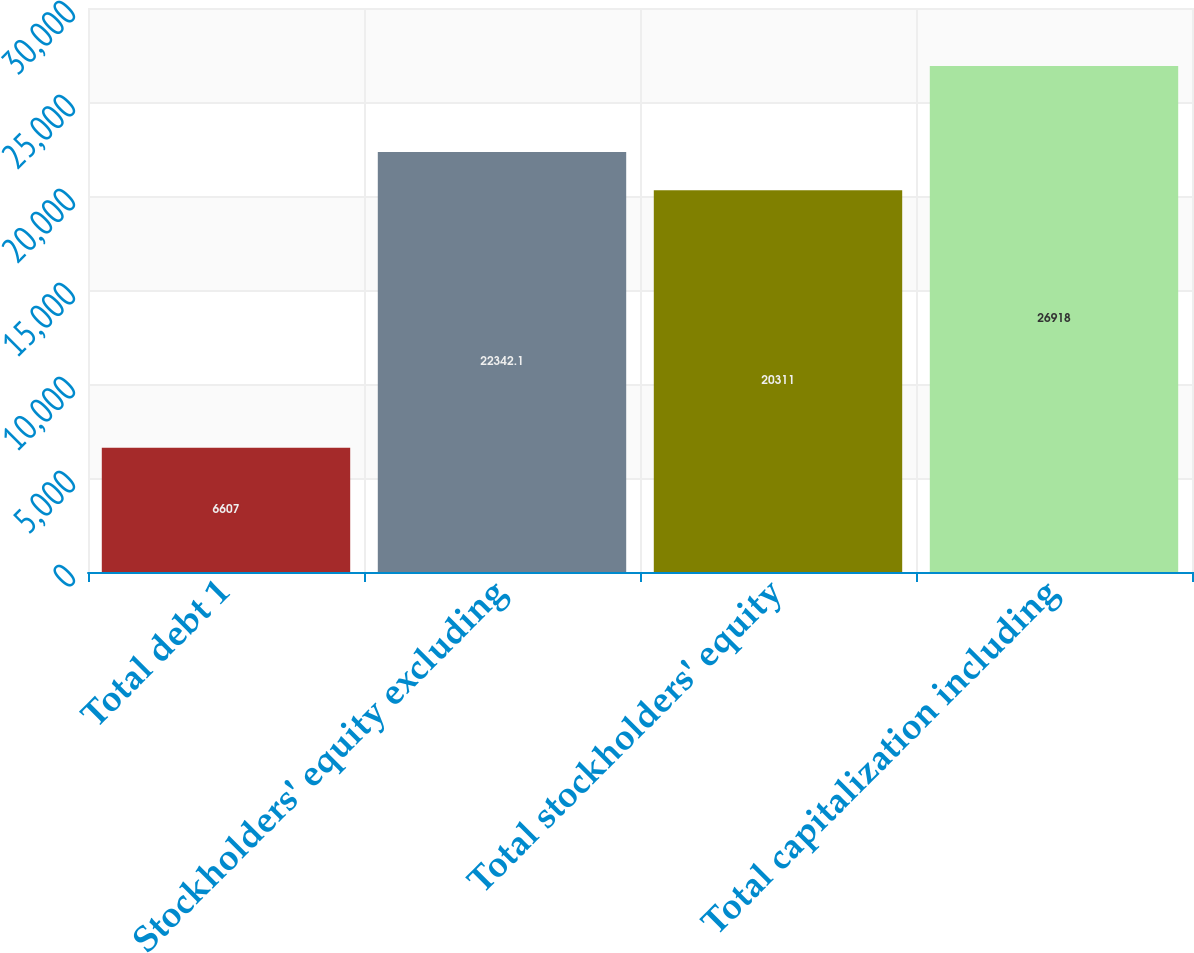<chart> <loc_0><loc_0><loc_500><loc_500><bar_chart><fcel>Total debt 1<fcel>Stockholders' equity excluding<fcel>Total stockholders' equity<fcel>Total capitalization including<nl><fcel>6607<fcel>22342.1<fcel>20311<fcel>26918<nl></chart> 